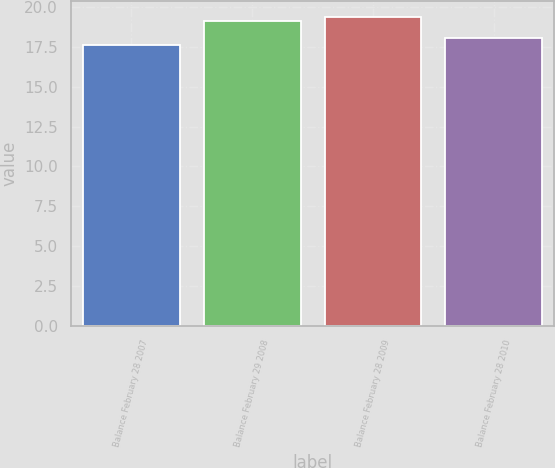Convert chart. <chart><loc_0><loc_0><loc_500><loc_500><bar_chart><fcel>Balance February 28 2007<fcel>Balance February 29 2008<fcel>Balance February 28 2009<fcel>Balance February 28 2010<nl><fcel>17.61<fcel>19.16<fcel>19.39<fcel>18.05<nl></chart> 